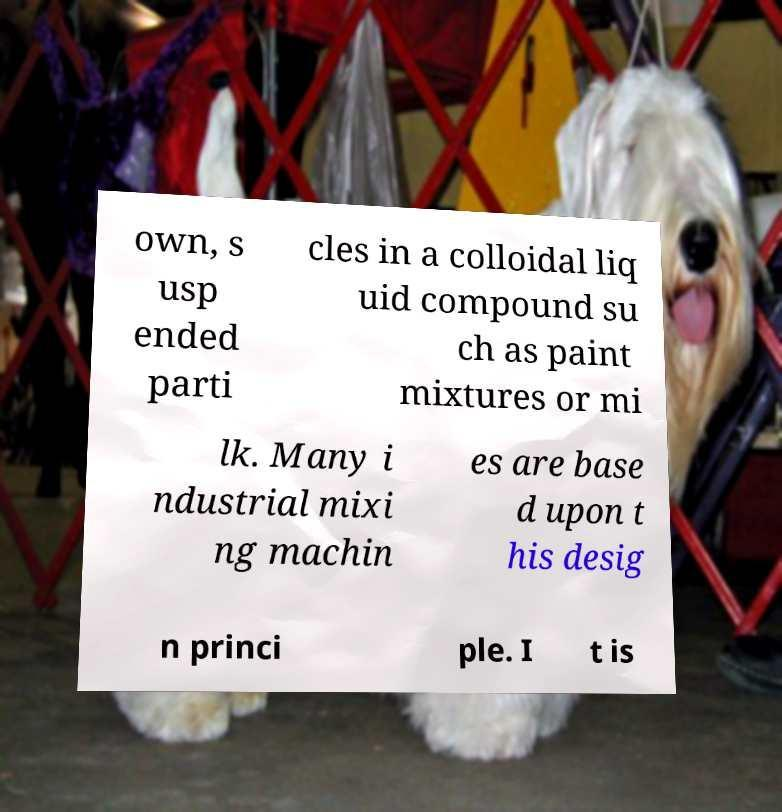Can you read and provide the text displayed in the image?This photo seems to have some interesting text. Can you extract and type it out for me? own, s usp ended parti cles in a colloidal liq uid compound su ch as paint mixtures or mi lk. Many i ndustrial mixi ng machin es are base d upon t his desig n princi ple. I t is 